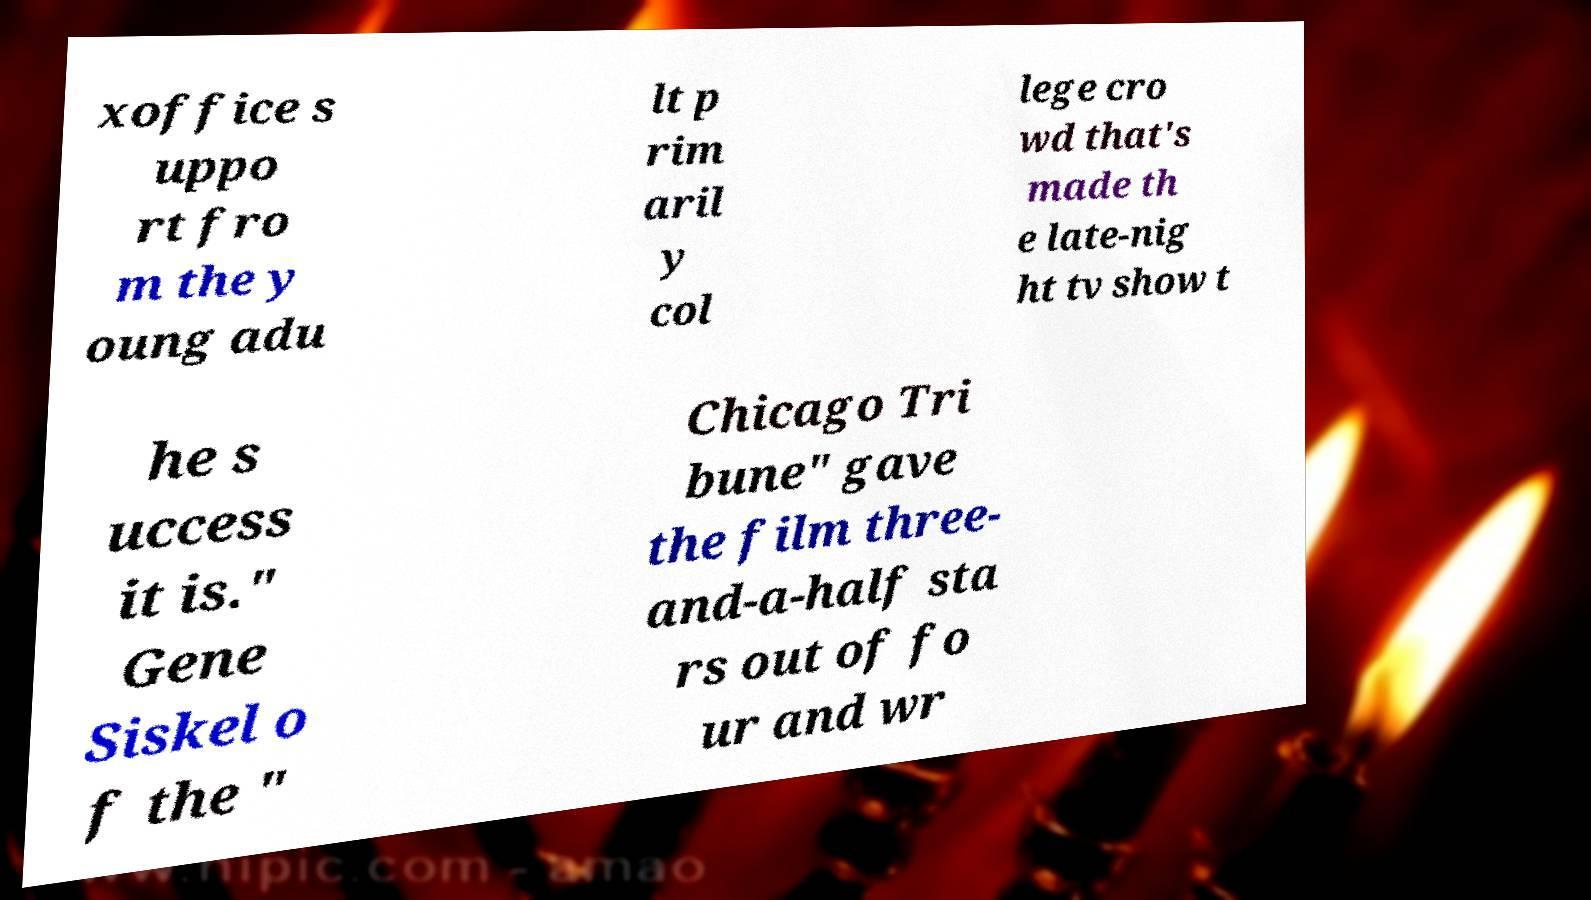Please read and relay the text visible in this image. What does it say? xoffice s uppo rt fro m the y oung adu lt p rim aril y col lege cro wd that's made th e late-nig ht tv show t he s uccess it is." Gene Siskel o f the " Chicago Tri bune" gave the film three- and-a-half sta rs out of fo ur and wr 